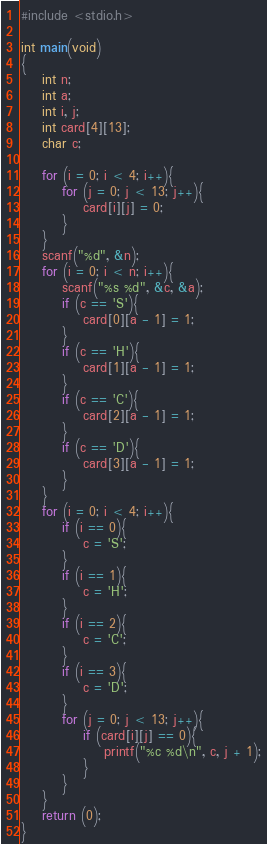Convert code to text. <code><loc_0><loc_0><loc_500><loc_500><_C_>#include <stdio.h>

int main(void)
{
	int n;
	int a;
	int i, j;
	int card[4][13];
	char c;
	 
	for (i = 0; i < 4; i++){
		for (j = 0; j < 13; j++){
			card[i][j] = 0;
		}
	}
	scanf("%d", &n);
	for (i = 0; i < n; i++){
		scanf("%s %d", &c, &a);
		if (c == 'S'){
			card[0][a - 1] = 1;
		}
		if (c == 'H'){
			card[1][a - 1] = 1;
		}
		if (c == 'C'){
			card[2][a - 1] = 1;
		}
		if (c == 'D'){
			card[3][a - 1] = 1;
		}
	}
	for (i = 0; i < 4; i++){
		if (i == 0){
			c = 'S';
		}
		if (i == 1){
			c = 'H';
		}
		if (i == 2){
			c = 'C';
		}
		if (i == 3){
			c = 'D';
		}
		for (j = 0; j < 13; j++){
			if (card[i][j] == 0){
				printf("%c %d\n", c, j + 1);
			}
		}
	}
	return (0);
}</code> 